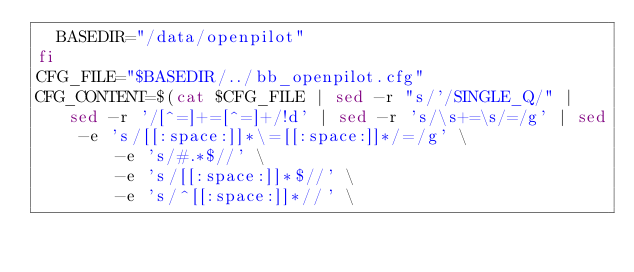<code> <loc_0><loc_0><loc_500><loc_500><_Bash_>  BASEDIR="/data/openpilot"
fi
CFG_FILE="$BASEDIR/../bb_openpilot.cfg"
CFG_CONTENT=$(cat $CFG_FILE | sed -r "s/'/SINGLE_Q/" | sed -r '/[^=]+=[^=]+/!d' | sed -r 's/\s+=\s/=/g' | sed -e 's/[[:space:]]*\=[[:space:]]*/=/g' \
        -e 's/#.*$//' \
        -e 's/[[:space:]]*$//' \
        -e 's/^[[:space:]]*//' \</code> 